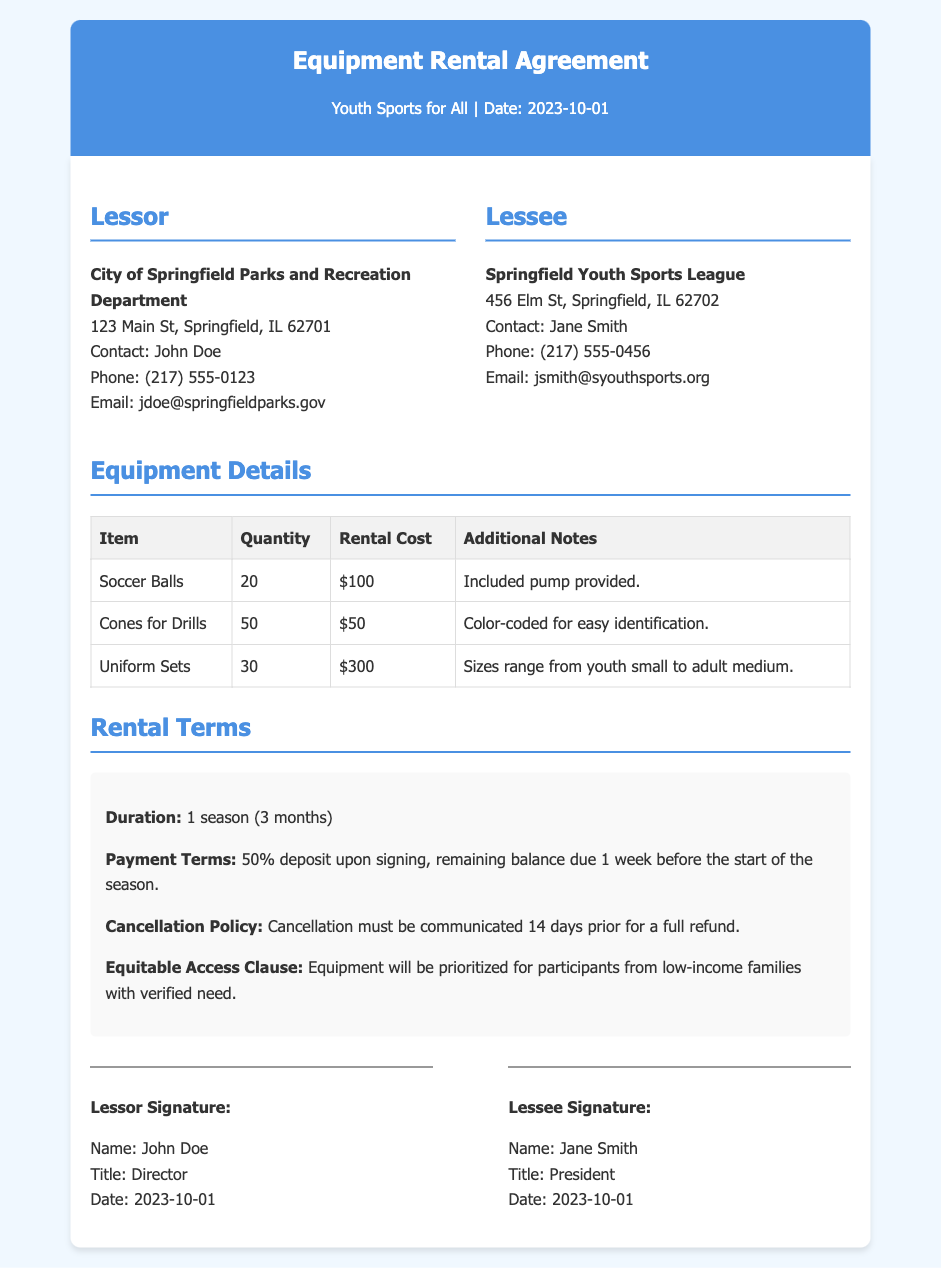What is the name of the lessor? The lessor is identified as the City of Springfield Parks and Recreation Department in the document.
Answer: City of Springfield Parks and Recreation Department What is the rental cost for the uniform sets? The rental cost for the uniform sets is explicitly stated in the equipment details table.
Answer: $300 Who is the contact person for the lessee? The document mentions Jane Smith as the contact for the Springfield Youth Sports League, which indicates her role.
Answer: Jane Smith How many soccer balls are included in the rental? The quantity of soccer balls is specified in the equipment details table under the item description.
Answer: 20 What is the duration of the rental agreement? The duration is specifically mentioned in the rental terms section of the document.
Answer: 1 season (3 months) What is the cancellation notice period for a full refund? The cancellation policy specifies the notice period required for a full refund, which is noted in the document.
Answer: 14 days What is the payment term structure? The payment terms are outlined in the rental terms section, indicating what percentage is due upon signing and when the remaining balance is due.
Answer: 50% deposit upon signing Who signed the agreement as the Lessor? The signature section indicates the individual who signed the agreement on behalf of the lessor.
Answer: John Doe What is the equitable access clause focused on? The equitable access clause of the document prioritizes access to equipment based on financial need.
Answer: Participants from low-income families with verified need 